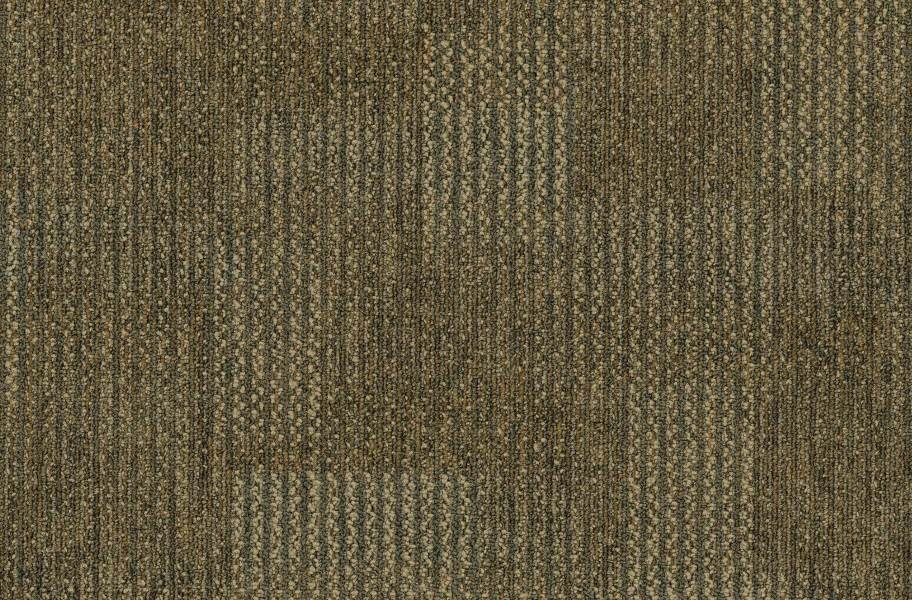How does the color and texture of this fabric influence its use in fashion and design? The earthy, muted green tone of this fabric, combined with the textured look provided by the herringbone weave, lends itself well to creating pieces that evoke a natural, organic feel. This makes it ideal for autumn and winter collections, blending seamlessly with seasonal color palettes. Its texture adds depth and interest to garments and furnishings, allowing designers to play with shadows and highlights in their creations, enhancing the visual appeal of the products. 